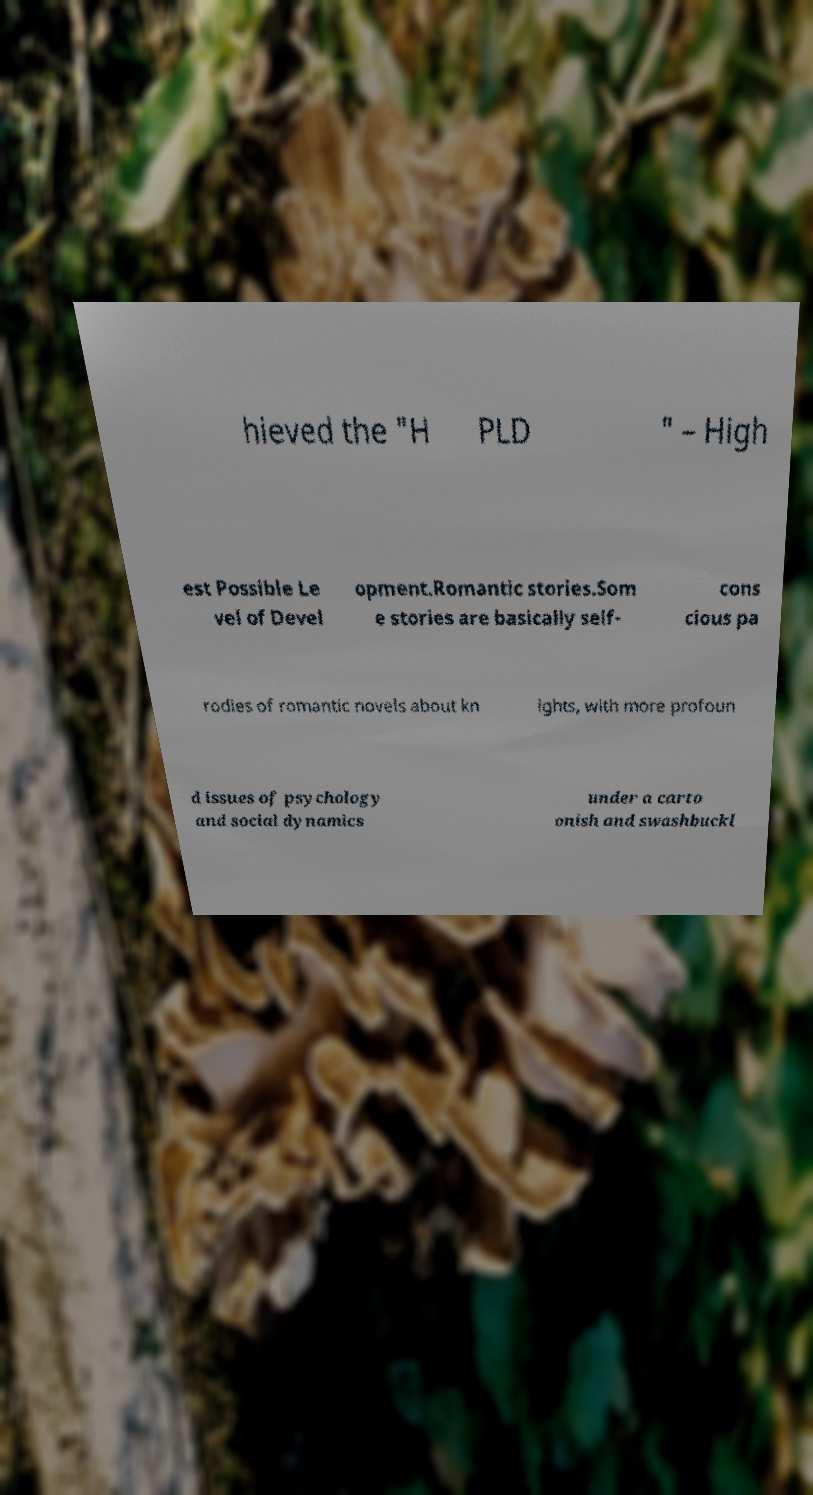Could you assist in decoding the text presented in this image and type it out clearly? hieved the "H PLD " – High est Possible Le vel of Devel opment.Romantic stories.Som e stories are basically self- cons cious pa rodies of romantic novels about kn ights, with more profoun d issues of psychology and social dynamics under a carto onish and swashbuckl 